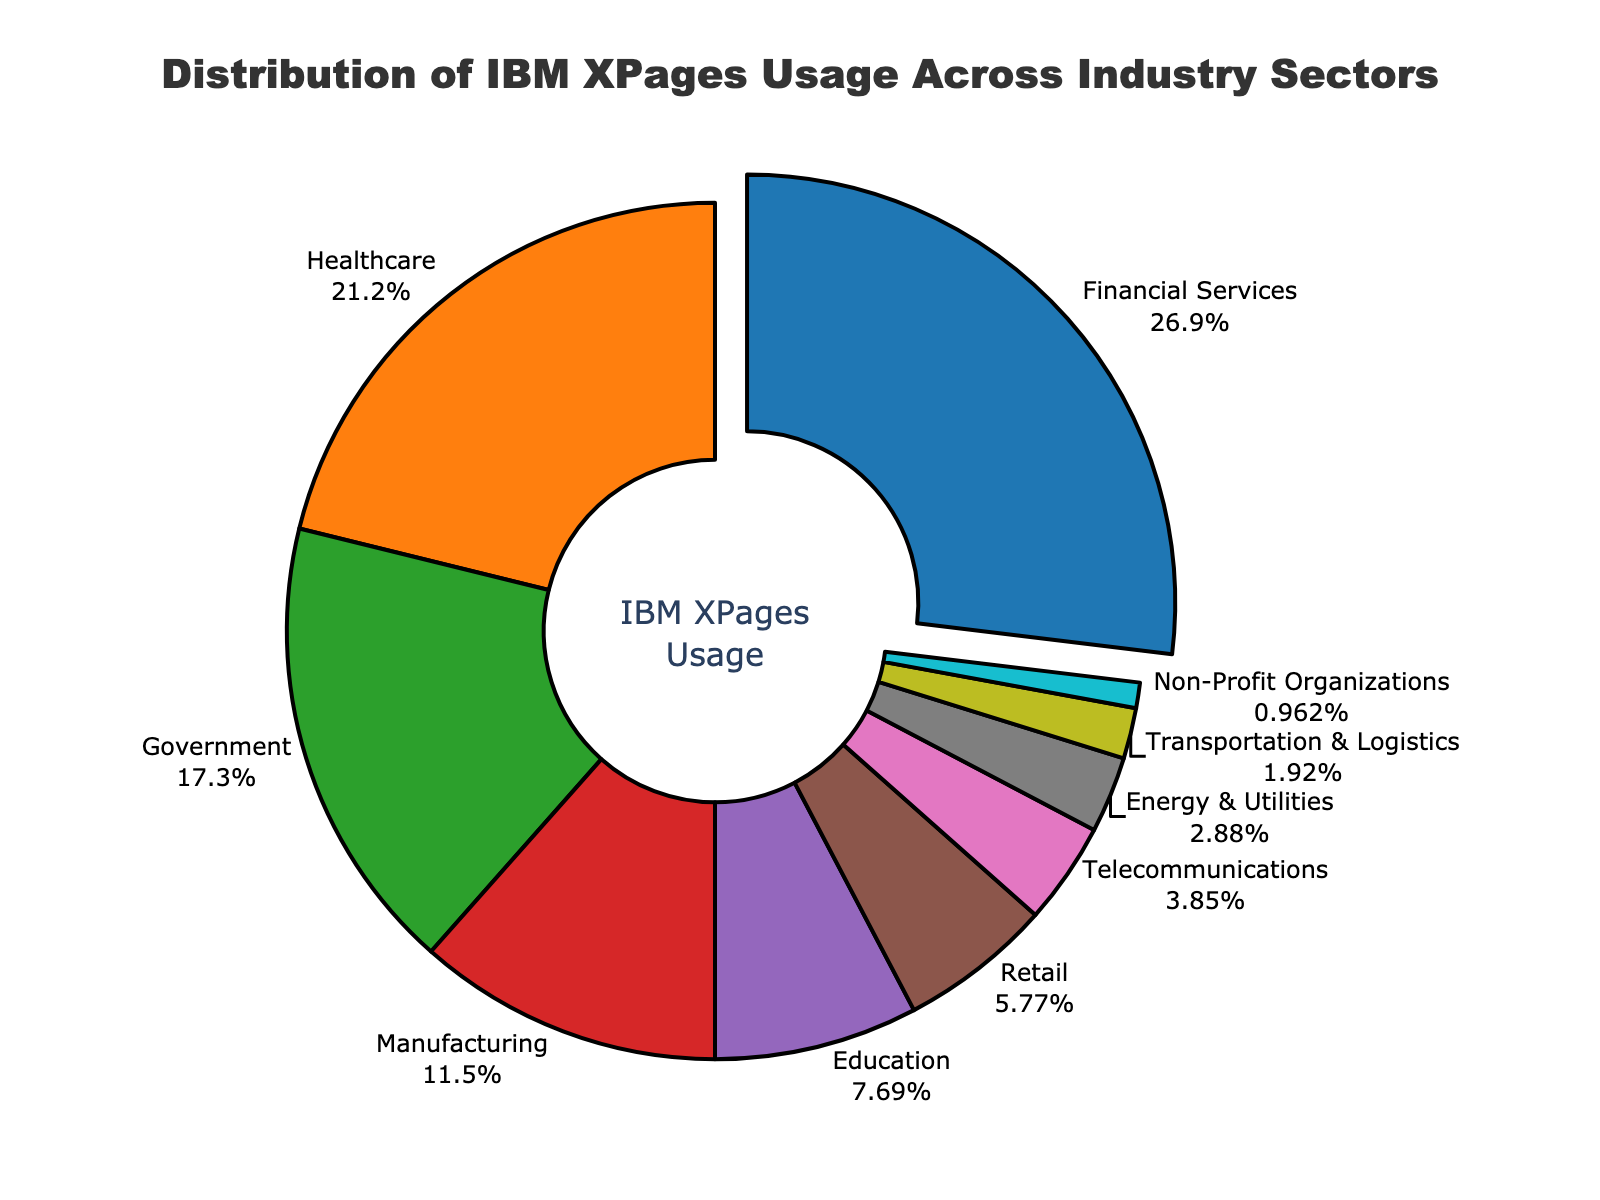What is the largest industry sector in terms of IBM XPages usage? The biggest sector corresponds to the pie slice that stands out the most in size and has been pulled from the center. It is labeled "Financial Services" with 28%.
Answer: Financial Services What industry sectors make up more than half of the total IBM XPages usage? To find sectors that make up more than 50%, add their percentages until the sum exceeds 50%. Summing the top percentages: Financial Services (28%) + Healthcare (22%) = 50%. Therefore, Financial Services and Healthcare together make up more than 50%.
Answer: Financial Services and Healthcare How much more IBM XPages usage is there in the Financial Services sector compared to the Education sector? To find the difference, subtract the percentage of the Education sector from the Financial Services sector: 28% - 8% = 20%.
Answer: 20% How many industry sectors have IBM XPages usage greater than the Retail sector? Identify sectors with percentages greater than the 6% of Retail: Financial Services (28%), Healthcare (22%), Government (18%), Manufacturing (12%), Education (8%). Count them to get 5 sectors.
Answer: 5 What is the combined percentage of IBM XPages usage by the Manufacturing and Telecommunications sectors? Add the percentages of Manufacturing (12%) and Telecommunications (4%): 12% + 4% = 16%.
Answer: 16% Which sector has the smallest percentage of IBM XPages usage? The smallest sector corresponds to the smallest pie slice, which is labeled "Non-Profit Organizations" with 1%.
Answer: Non-Profit Organizations Is the proportion of IBM XPages usage in the Government sector greater than that in the Retail and Telecommunications sectors combined? Sum the percentages of Retail (6%) and Telecommunications (4%) to get 10%. Compare it with Government's 18%. Since 18% is greater than 10%, Government has a greater proportion.
Answer: Yes What are the top three sectors by IBM XPages usage, and what cumulative percentage do they represent? Identify the top three sectors: Financial Services (28%), Healthcare (22%), and Government (18%). Add their percentages: 28% + 22% + 18% = 68%.
Answer: Financial Services, Healthcare, Government, 68% How does the IBM XPages usage in Energy & Utilities compare to that in Transportation & Logistics? Compare the percentages of Energy & Utilities (3%) and Transportation & Logistics (2%). Energy & Utilities has a 1% higher usage.
Answer: Energy & Utilities has 1% more 